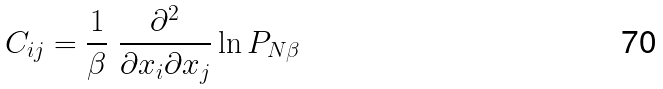Convert formula to latex. <formula><loc_0><loc_0><loc_500><loc_500>C _ { i j } = \frac { 1 } { \beta } \ \frac { \partial ^ { 2 } } { \partial x _ { i } \partial x _ { j } } \ln P _ { N \beta }</formula> 